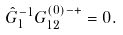<formula> <loc_0><loc_0><loc_500><loc_500>\hat { G } ^ { - 1 } _ { 1 } G ^ { ( 0 ) - + } _ { 1 2 } = 0 .</formula> 